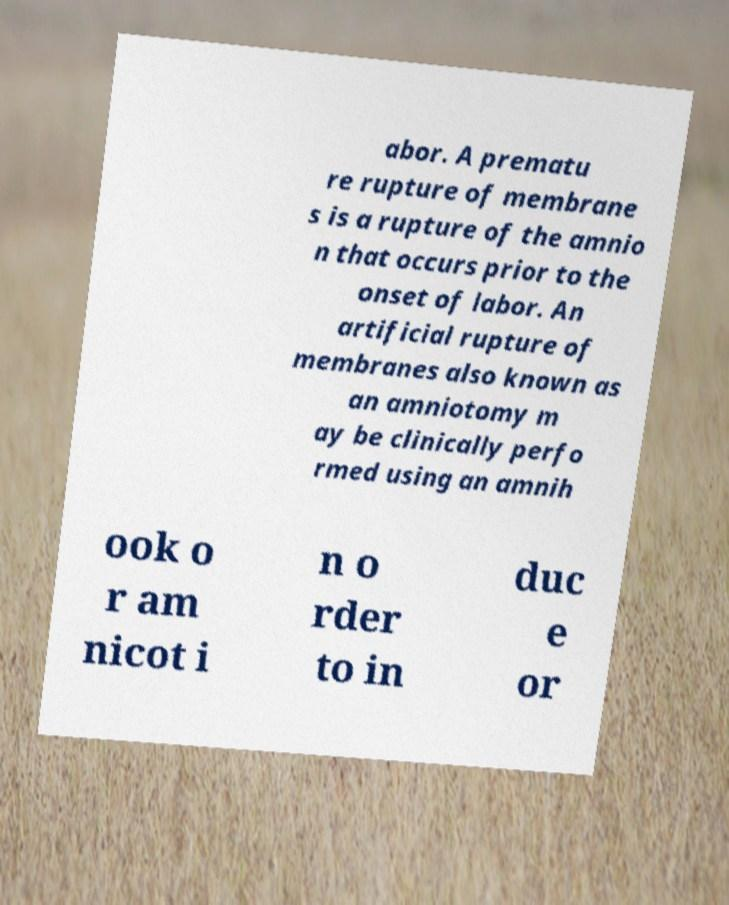Could you extract and type out the text from this image? abor. A prematu re rupture of membrane s is a rupture of the amnio n that occurs prior to the onset of labor. An artificial rupture of membranes also known as an amniotomy m ay be clinically perfo rmed using an amnih ook o r am nicot i n o rder to in duc e or 